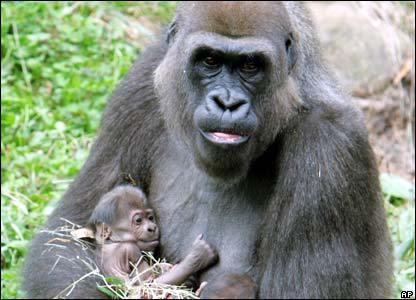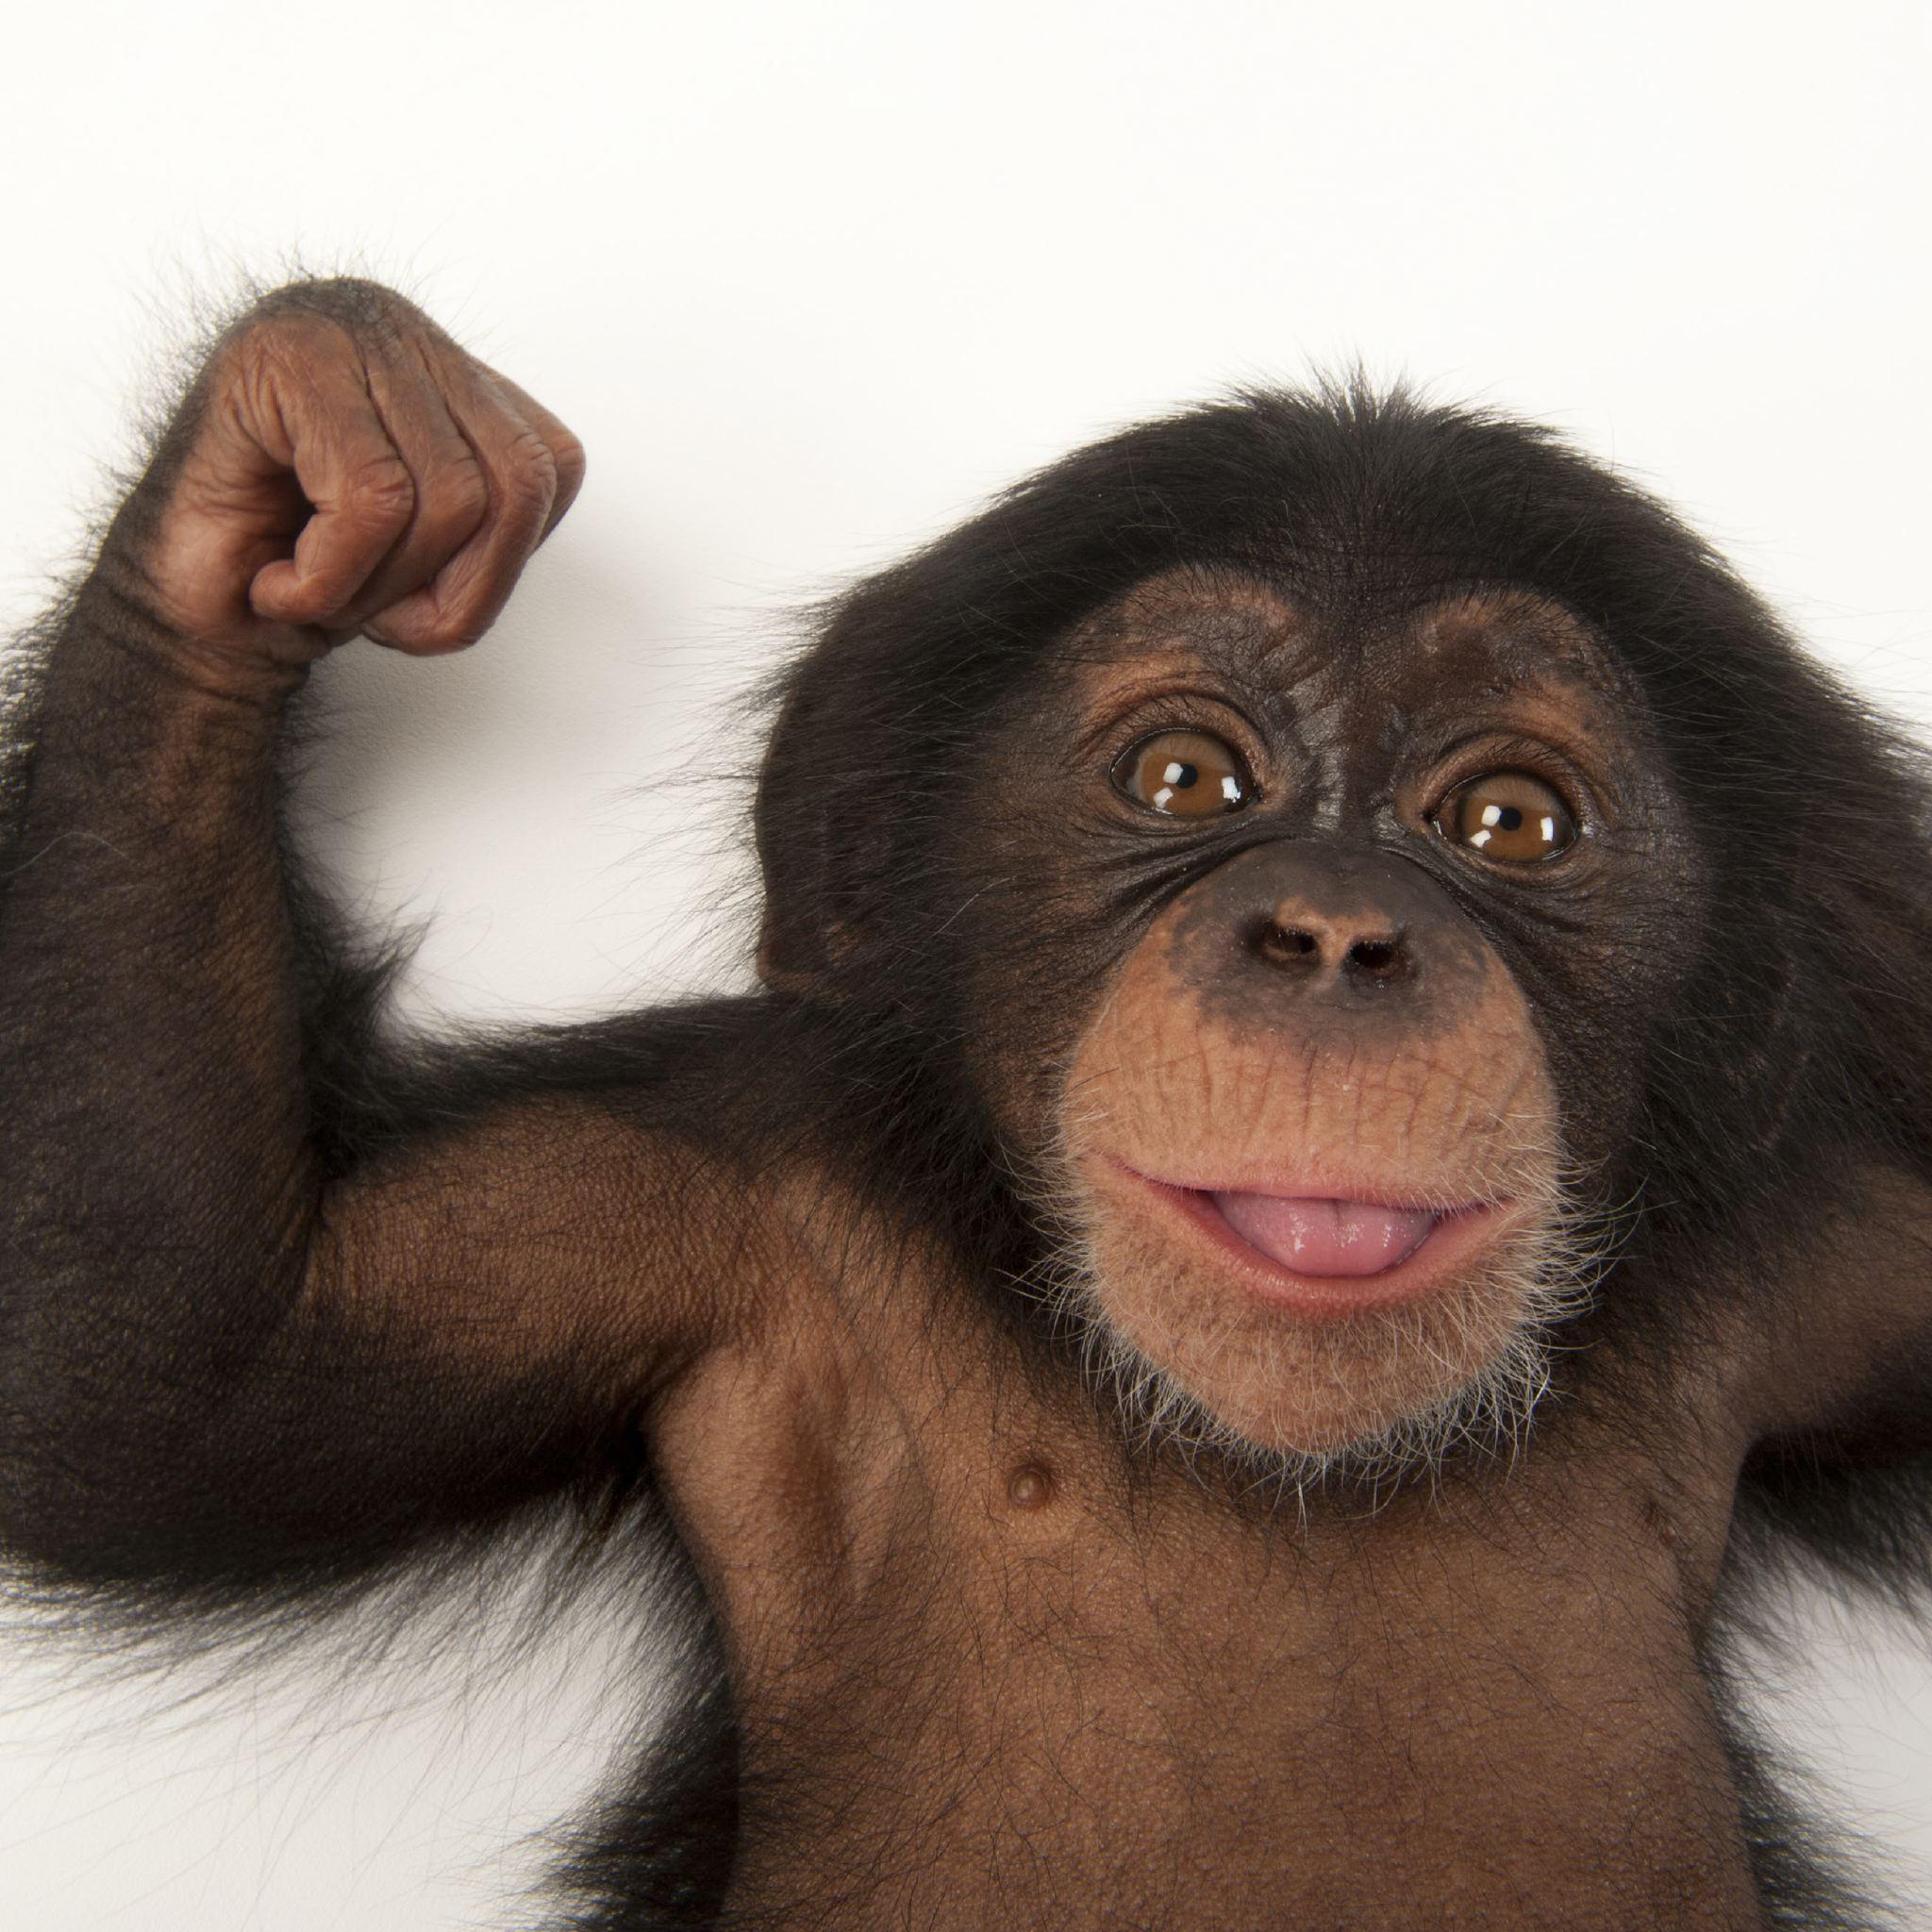The first image is the image on the left, the second image is the image on the right. Assess this claim about the two images: "An image shows two very similar looking young chimps side by side.". Correct or not? Answer yes or no. No. The first image is the image on the left, the second image is the image on the right. Assess this claim about the two images: "One of the images shows only one animal.". Correct or not? Answer yes or no. Yes. 